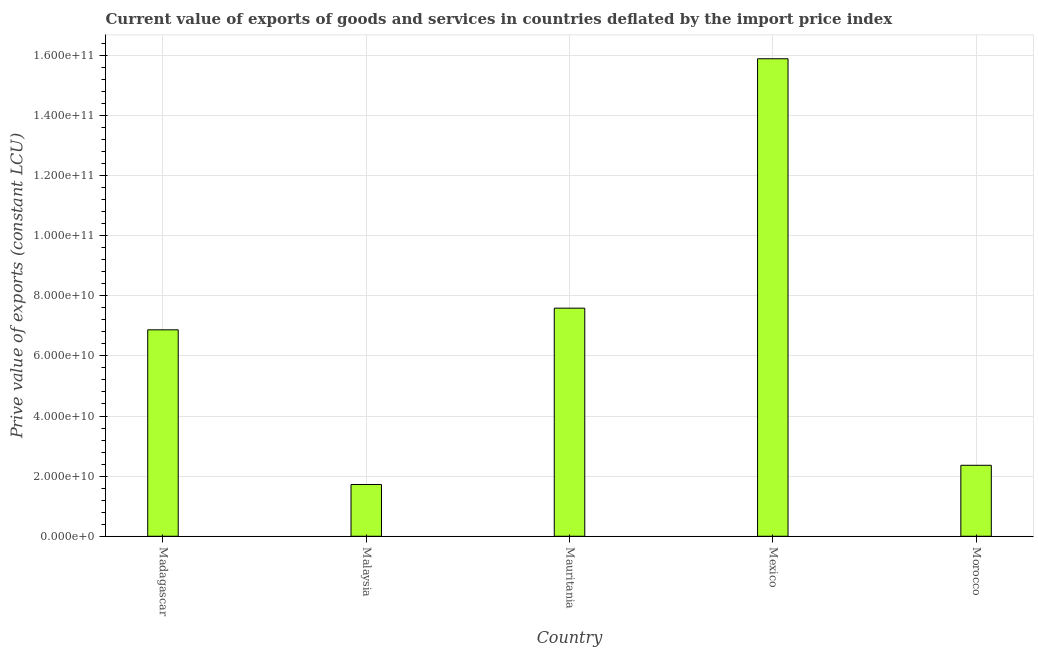Does the graph contain grids?
Your response must be concise. Yes. What is the title of the graph?
Offer a terse response. Current value of exports of goods and services in countries deflated by the import price index. What is the label or title of the X-axis?
Your answer should be compact. Country. What is the label or title of the Y-axis?
Keep it short and to the point. Prive value of exports (constant LCU). What is the price value of exports in Morocco?
Offer a very short reply. 2.36e+1. Across all countries, what is the maximum price value of exports?
Provide a short and direct response. 1.59e+11. Across all countries, what is the minimum price value of exports?
Offer a very short reply. 1.72e+1. In which country was the price value of exports maximum?
Make the answer very short. Mexico. In which country was the price value of exports minimum?
Keep it short and to the point. Malaysia. What is the sum of the price value of exports?
Your answer should be very brief. 3.44e+11. What is the difference between the price value of exports in Mauritania and Morocco?
Provide a short and direct response. 5.23e+1. What is the average price value of exports per country?
Keep it short and to the point. 6.88e+1. What is the median price value of exports?
Your answer should be compact. 6.87e+1. In how many countries, is the price value of exports greater than 128000000000 LCU?
Make the answer very short. 1. What is the ratio of the price value of exports in Malaysia to that in Mexico?
Your answer should be compact. 0.11. What is the difference between the highest and the second highest price value of exports?
Your answer should be very brief. 8.30e+1. What is the difference between the highest and the lowest price value of exports?
Make the answer very short. 1.42e+11. Are all the bars in the graph horizontal?
Your response must be concise. No. What is the Prive value of exports (constant LCU) in Madagascar?
Provide a succinct answer. 6.87e+1. What is the Prive value of exports (constant LCU) in Malaysia?
Offer a very short reply. 1.72e+1. What is the Prive value of exports (constant LCU) in Mauritania?
Provide a short and direct response. 7.59e+1. What is the Prive value of exports (constant LCU) in Mexico?
Offer a terse response. 1.59e+11. What is the Prive value of exports (constant LCU) in Morocco?
Make the answer very short. 2.36e+1. What is the difference between the Prive value of exports (constant LCU) in Madagascar and Malaysia?
Your response must be concise. 5.15e+1. What is the difference between the Prive value of exports (constant LCU) in Madagascar and Mauritania?
Provide a succinct answer. -7.20e+09. What is the difference between the Prive value of exports (constant LCU) in Madagascar and Mexico?
Give a very brief answer. -9.02e+1. What is the difference between the Prive value of exports (constant LCU) in Madagascar and Morocco?
Keep it short and to the point. 4.51e+1. What is the difference between the Prive value of exports (constant LCU) in Malaysia and Mauritania?
Ensure brevity in your answer.  -5.87e+1. What is the difference between the Prive value of exports (constant LCU) in Malaysia and Mexico?
Offer a very short reply. -1.42e+11. What is the difference between the Prive value of exports (constant LCU) in Malaysia and Morocco?
Give a very brief answer. -6.39e+09. What is the difference between the Prive value of exports (constant LCU) in Mauritania and Mexico?
Your answer should be very brief. -8.30e+1. What is the difference between the Prive value of exports (constant LCU) in Mauritania and Morocco?
Ensure brevity in your answer.  5.23e+1. What is the difference between the Prive value of exports (constant LCU) in Mexico and Morocco?
Ensure brevity in your answer.  1.35e+11. What is the ratio of the Prive value of exports (constant LCU) in Madagascar to that in Malaysia?
Your answer should be very brief. 3.99. What is the ratio of the Prive value of exports (constant LCU) in Madagascar to that in Mauritania?
Provide a succinct answer. 0.91. What is the ratio of the Prive value of exports (constant LCU) in Madagascar to that in Mexico?
Provide a succinct answer. 0.43. What is the ratio of the Prive value of exports (constant LCU) in Madagascar to that in Morocco?
Your response must be concise. 2.91. What is the ratio of the Prive value of exports (constant LCU) in Malaysia to that in Mauritania?
Your answer should be compact. 0.23. What is the ratio of the Prive value of exports (constant LCU) in Malaysia to that in Mexico?
Offer a very short reply. 0.11. What is the ratio of the Prive value of exports (constant LCU) in Malaysia to that in Morocco?
Keep it short and to the point. 0.73. What is the ratio of the Prive value of exports (constant LCU) in Mauritania to that in Mexico?
Provide a short and direct response. 0.48. What is the ratio of the Prive value of exports (constant LCU) in Mauritania to that in Morocco?
Make the answer very short. 3.21. What is the ratio of the Prive value of exports (constant LCU) in Mexico to that in Morocco?
Make the answer very short. 6.73. 